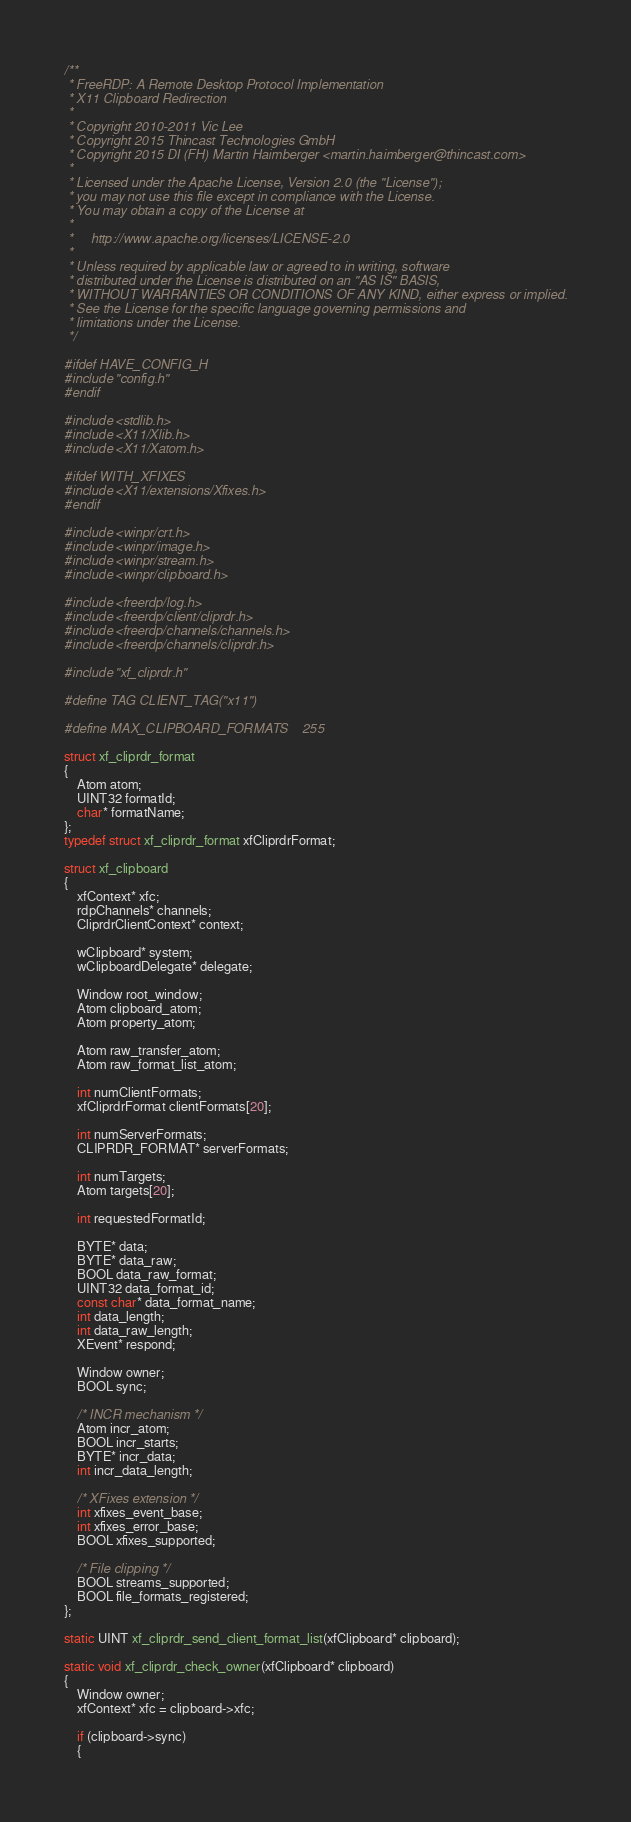Convert code to text. <code><loc_0><loc_0><loc_500><loc_500><_C_>/**
 * FreeRDP: A Remote Desktop Protocol Implementation
 * X11 Clipboard Redirection
 *
 * Copyright 2010-2011 Vic Lee
 * Copyright 2015 Thincast Technologies GmbH
 * Copyright 2015 DI (FH) Martin Haimberger <martin.haimberger@thincast.com>
 *
 * Licensed under the Apache License, Version 2.0 (the "License");
 * you may not use this file except in compliance with the License.
 * You may obtain a copy of the License at
 *
 *     http://www.apache.org/licenses/LICENSE-2.0
 *
 * Unless required by applicable law or agreed to in writing, software
 * distributed under the License is distributed on an "AS IS" BASIS,
 * WITHOUT WARRANTIES OR CONDITIONS OF ANY KIND, either express or implied.
 * See the License for the specific language governing permissions and
 * limitations under the License.
 */

#ifdef HAVE_CONFIG_H
#include "config.h"
#endif

#include <stdlib.h>
#include <X11/Xlib.h>
#include <X11/Xatom.h>

#ifdef WITH_XFIXES
#include <X11/extensions/Xfixes.h>
#endif

#include <winpr/crt.h>
#include <winpr/image.h>
#include <winpr/stream.h>
#include <winpr/clipboard.h>

#include <freerdp/log.h>
#include <freerdp/client/cliprdr.h>
#include <freerdp/channels/channels.h>
#include <freerdp/channels/cliprdr.h>

#include "xf_cliprdr.h"

#define TAG CLIENT_TAG("x11")

#define MAX_CLIPBOARD_FORMATS	255

struct xf_cliprdr_format
{
	Atom atom;
	UINT32 formatId;
	char* formatName;
};
typedef struct xf_cliprdr_format xfCliprdrFormat;

struct xf_clipboard
{
	xfContext* xfc;
	rdpChannels* channels;
	CliprdrClientContext* context;

	wClipboard* system;
	wClipboardDelegate* delegate;

	Window root_window;
	Atom clipboard_atom;
	Atom property_atom;

	Atom raw_transfer_atom;
	Atom raw_format_list_atom;

	int numClientFormats;
	xfCliprdrFormat clientFormats[20];

	int numServerFormats;
	CLIPRDR_FORMAT* serverFormats;

	int numTargets;
	Atom targets[20];

	int requestedFormatId;

	BYTE* data;
	BYTE* data_raw;
	BOOL data_raw_format;
	UINT32 data_format_id;
	const char* data_format_name;
	int data_length;
	int data_raw_length;
	XEvent* respond;

	Window owner;
	BOOL sync;

	/* INCR mechanism */
	Atom incr_atom;
	BOOL incr_starts;
	BYTE* incr_data;
	int incr_data_length;

	/* XFixes extension */
	int xfixes_event_base;
	int xfixes_error_base;
	BOOL xfixes_supported;

	/* File clipping */
	BOOL streams_supported;
	BOOL file_formats_registered;
};

static UINT xf_cliprdr_send_client_format_list(xfClipboard* clipboard);

static void xf_cliprdr_check_owner(xfClipboard* clipboard)
{
	Window owner;
	xfContext* xfc = clipboard->xfc;

	if (clipboard->sync)
	{</code> 